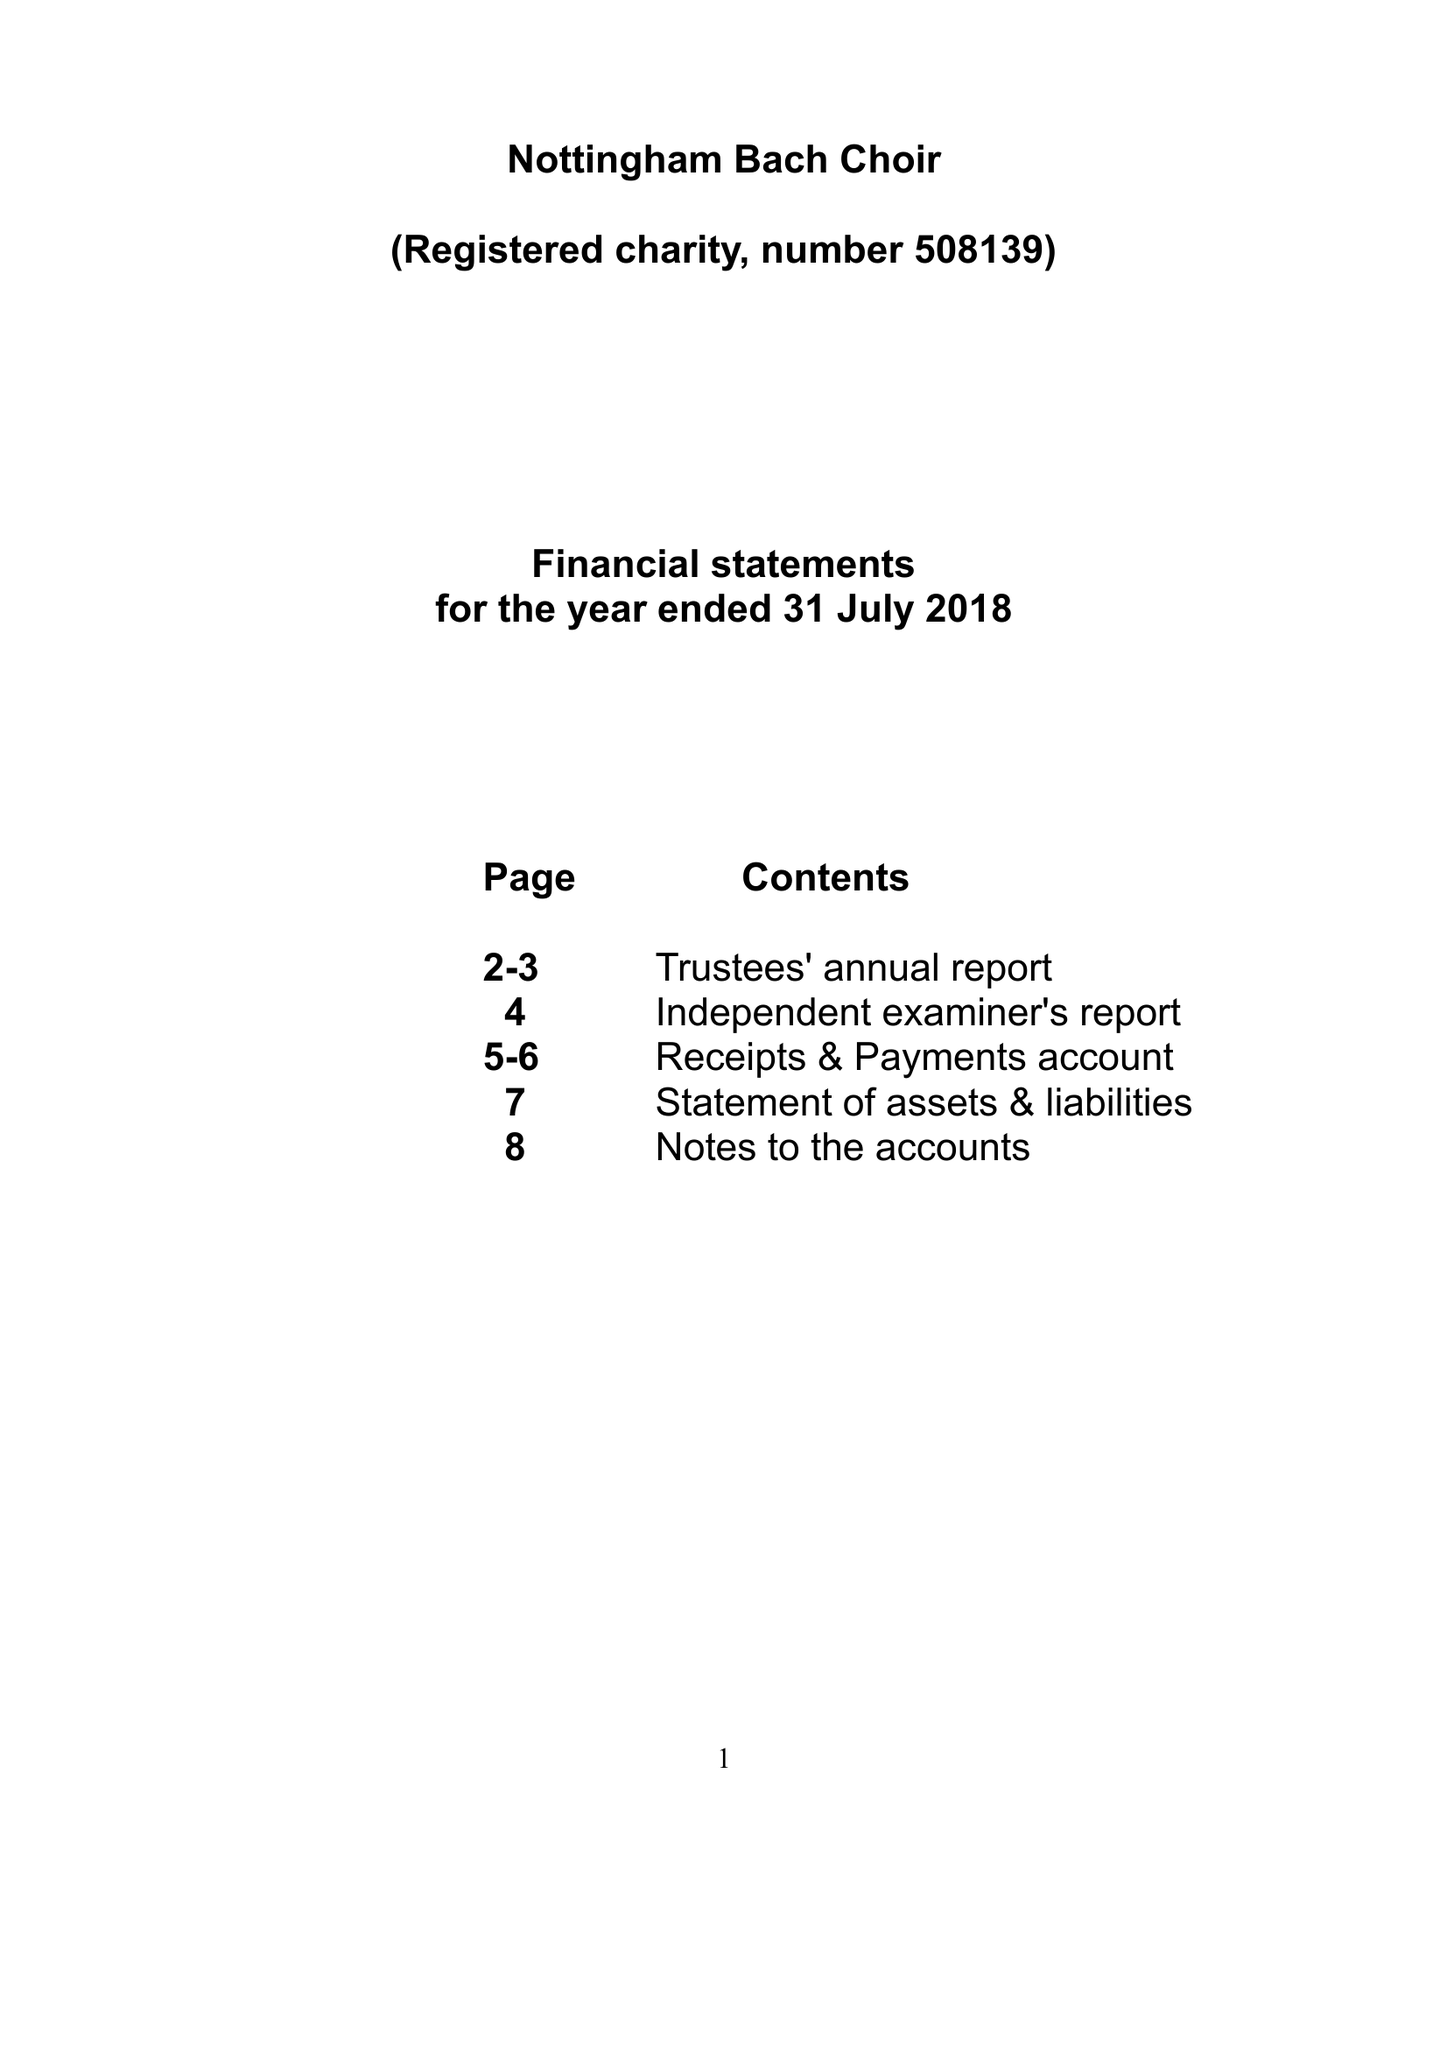What is the value for the spending_annually_in_british_pounds?
Answer the question using a single word or phrase. 36520.95 